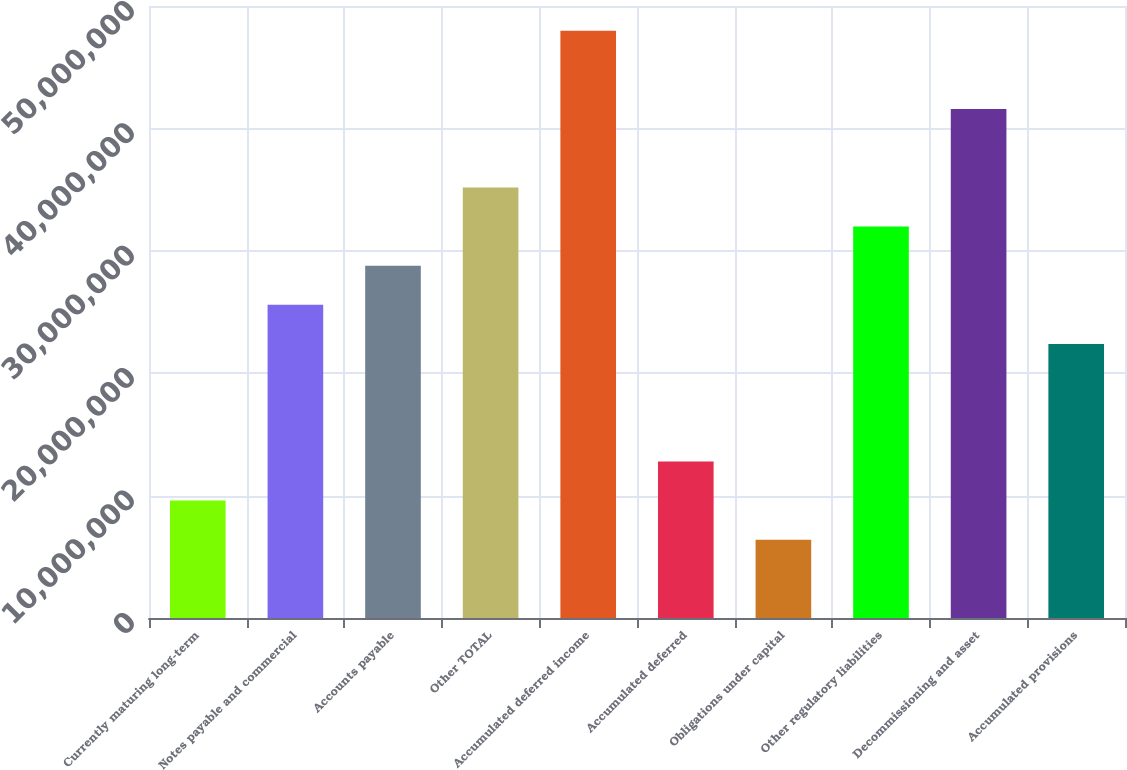Convert chart. <chart><loc_0><loc_0><loc_500><loc_500><bar_chart><fcel>Currently maturing long-term<fcel>Notes payable and commercial<fcel>Accounts payable<fcel>Other TOTAL<fcel>Accumulated deferred income<fcel>Accumulated deferred<fcel>Obligations under capital<fcel>Other regulatory liabilities<fcel>Decommissioning and asset<fcel>Accumulated provisions<nl><fcel>9.59661e+06<fcel>2.55867e+07<fcel>2.87847e+07<fcel>3.51808e+07<fcel>4.79728e+07<fcel>1.27946e+07<fcel>6.39859e+06<fcel>3.19827e+07<fcel>4.15768e+07<fcel>2.23887e+07<nl></chart> 